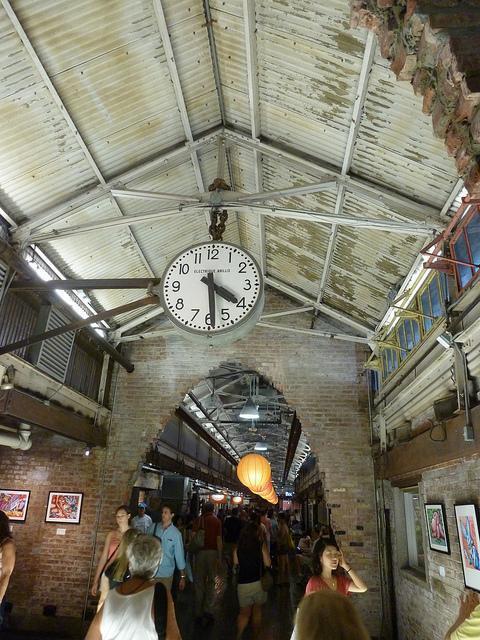How many people are in the picture?
Give a very brief answer. 5. How many birds are standing on the boat?
Give a very brief answer. 0. 